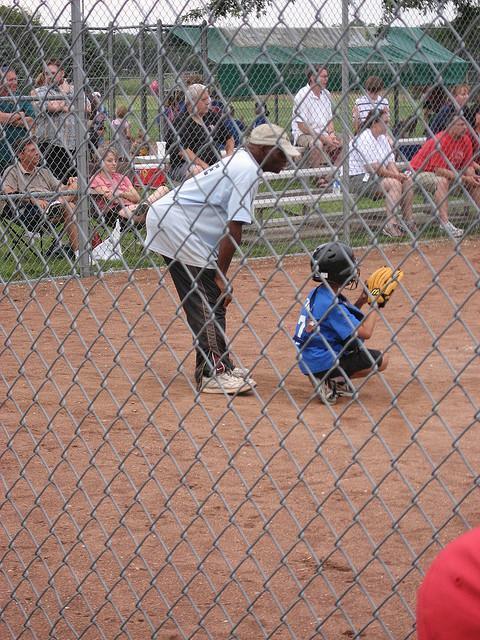How many benches are there for the crowd to sit on?
Give a very brief answer. 3. How many people are there?
Give a very brief answer. 9. 